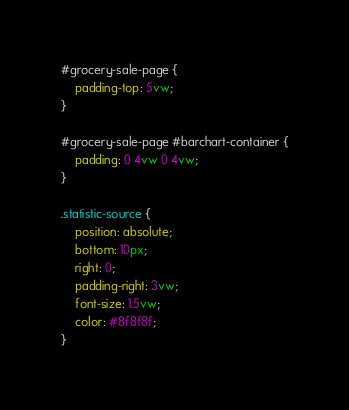<code> <loc_0><loc_0><loc_500><loc_500><_CSS_>#grocery-sale-page {
    padding-top: 5vw;
}

#grocery-sale-page #barchart-container {
    padding: 0 4vw 0 4vw;
}

.statistic-source {
    position: absolute;
    bottom: 10px;
    right: 0;
    padding-right: 3vw; 
    font-size: 1.5vw;
    color: #8f8f8f;
}</code> 